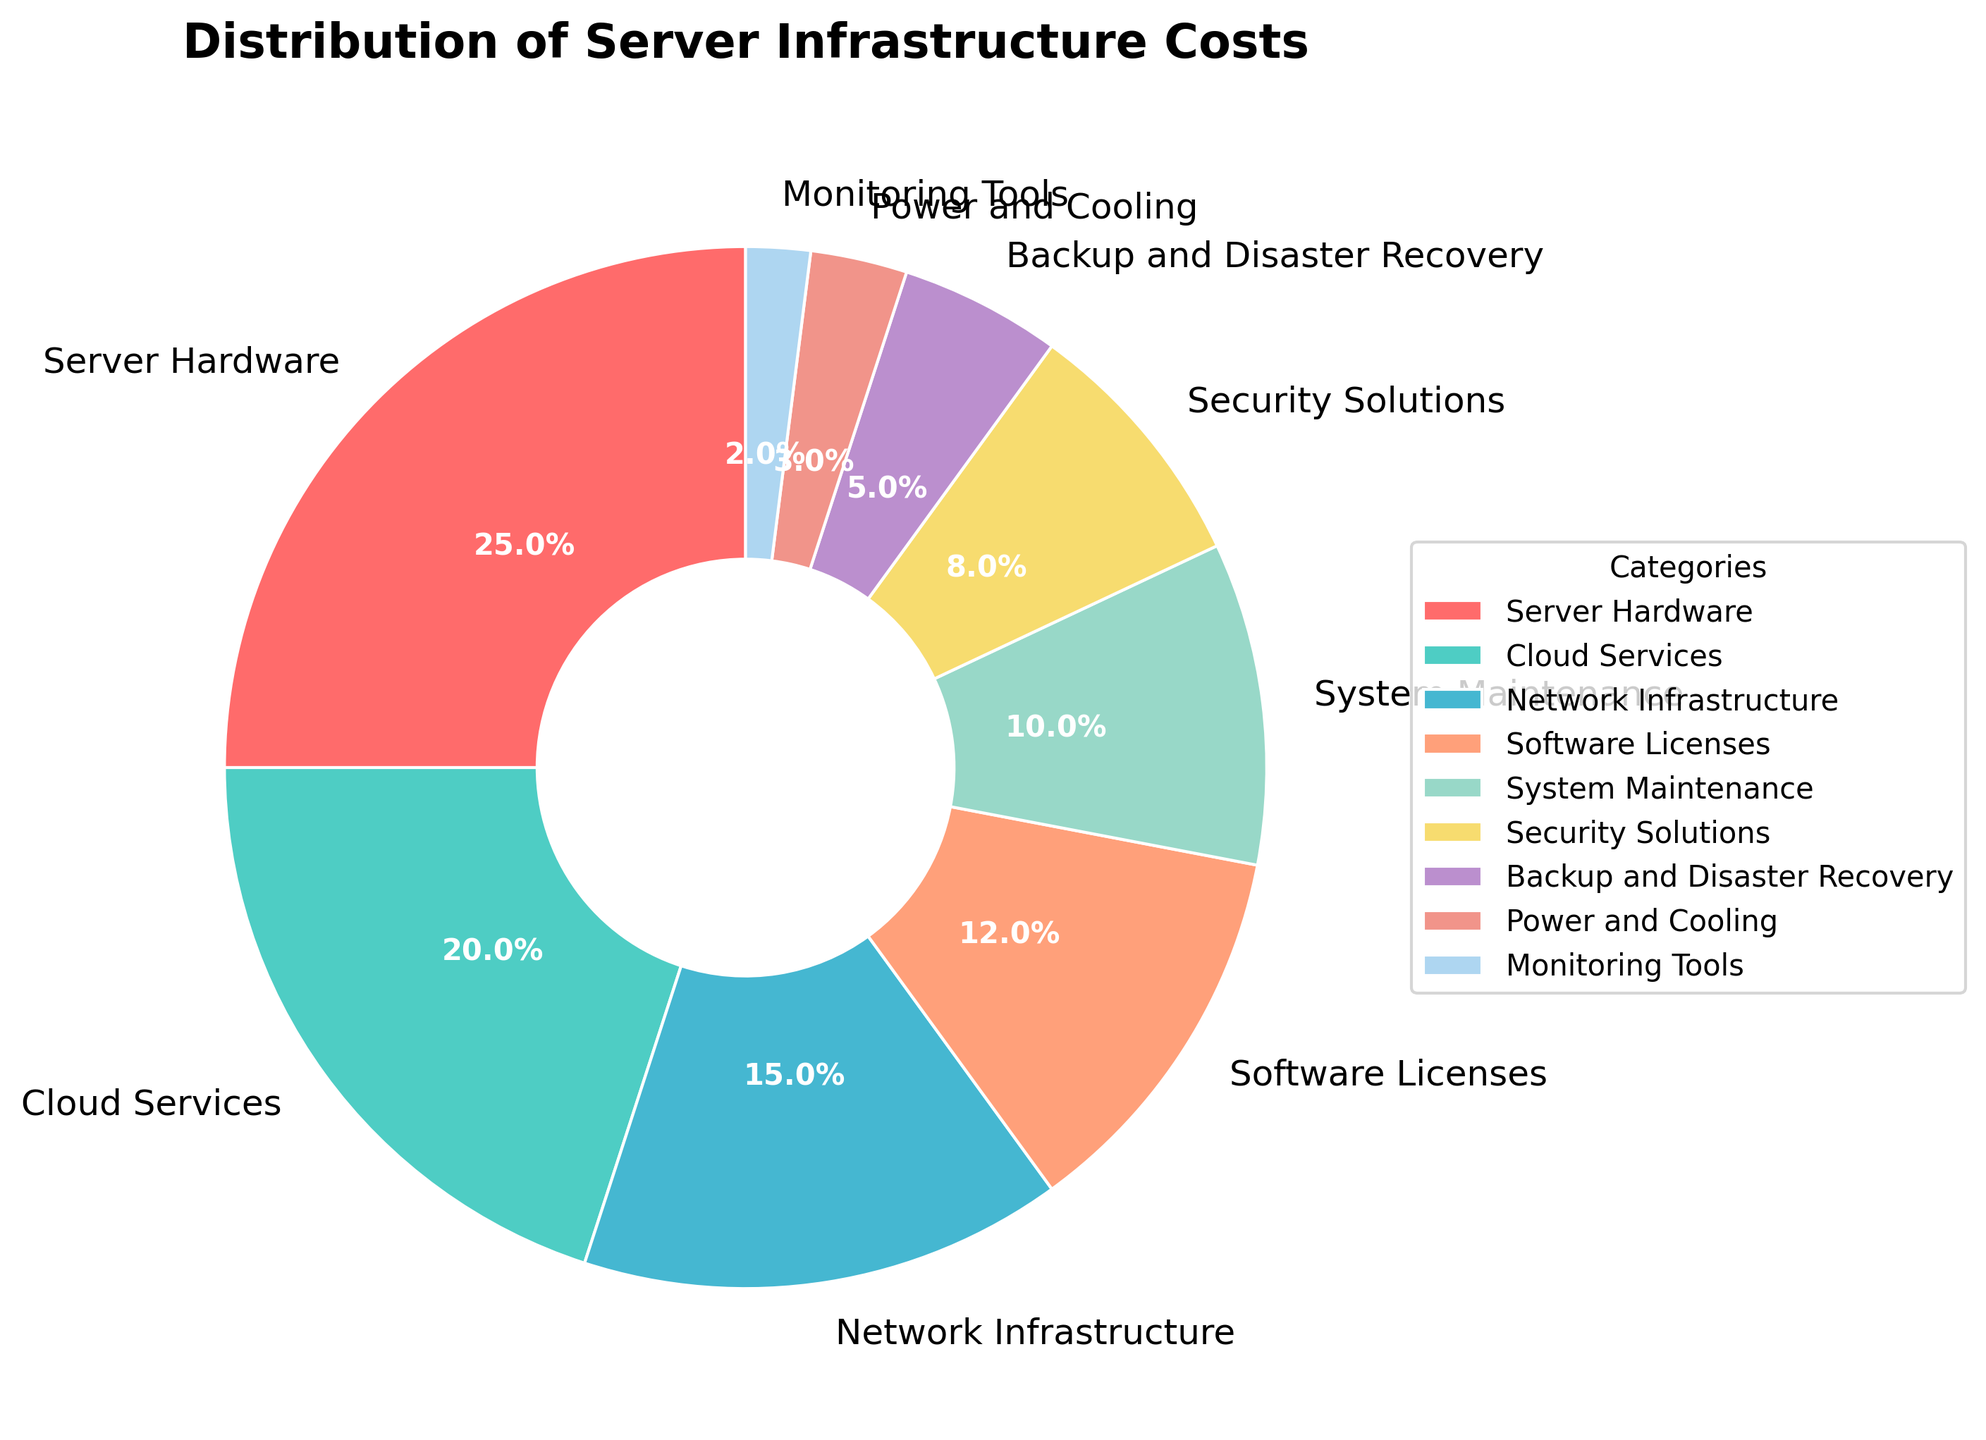What is the largest category in the distribution of server infrastructure costs? The pie chart shows that the largest wedge represents "Server Hardware" with a percentage of 25%.
Answer: Server Hardware What is the combined percentage of "Network Infrastructure" and "Security Solutions"? The pie chart shows that "Network Infrastructure" is 15% and "Security Solutions" is 8%. Adding these together gives 15% + 8% = 23%.
Answer: 23% Which categories are less than 10% of the total distribution? From the pie chart, the categories "System Maintenance" (10%), "Security Solutions" (8%), "Backup and Disaster Recovery" (5%), "Power and Cooling" (3%), and "Monitoring Tools" (2%) are all less than 10%.
Answer: System Maintenance, Security Solutions, Backup and Disaster Recovery, Power and Cooling, Monitoring Tools Is "Cloud Services" cost higher or lower than "Software Licenses" cost? The pie chart shows "Cloud Services" at 20% and "Software Licenses" at 12%, so "Cloud Services" costs are higher.
Answer: Higher What is the total percentage of the top three categories combined? The top three categories are "Server Hardware" (25%), "Cloud Services" (20%), and "Network Infrastructure" (15%). Adding these gives 25% + 20% + 15% = 60%.
Answer: 60% How much larger is the "Server Hardware" cost compared to "Backup and Disaster Recovery" cost? The "Server Hardware" cost is 25% and the "Backup and Disaster Recovery" cost is 5%. The difference is 25% - 5% = 20%.
Answer: 20% Which category has the smallest percentage, and what is its value? From the pie chart, "Monitoring Tools" is the smallest category with a percentage of 2%.
Answer: Monitoring Tools, 2% Describe the visual appearance of the wedge representing "System Maintenance". The wedge representing "System Maintenance" has a medium size and is in light brown color.
Answer: Medium size, light brown color What percentage of costs is allocated to categories related to software, including "Software Licenses" and "Monitoring Tools"? The "Software Licenses" category is 12% and the "Monitoring Tools" category is 2%. Adding these together gives 12% + 2% = 14%.
Answer: 14% Is the total percentage of "Power and Cooling" plus "Backup and Disaster Recovery" greater or smaller than "Cloud Services"? "Power and Cooling" is 3% and "Backup and Disaster Recovery" is 5%. Adding these gives 3% + 5% = 8%, which is smaller than "Cloud Services" at 20%.
Answer: Smaller 